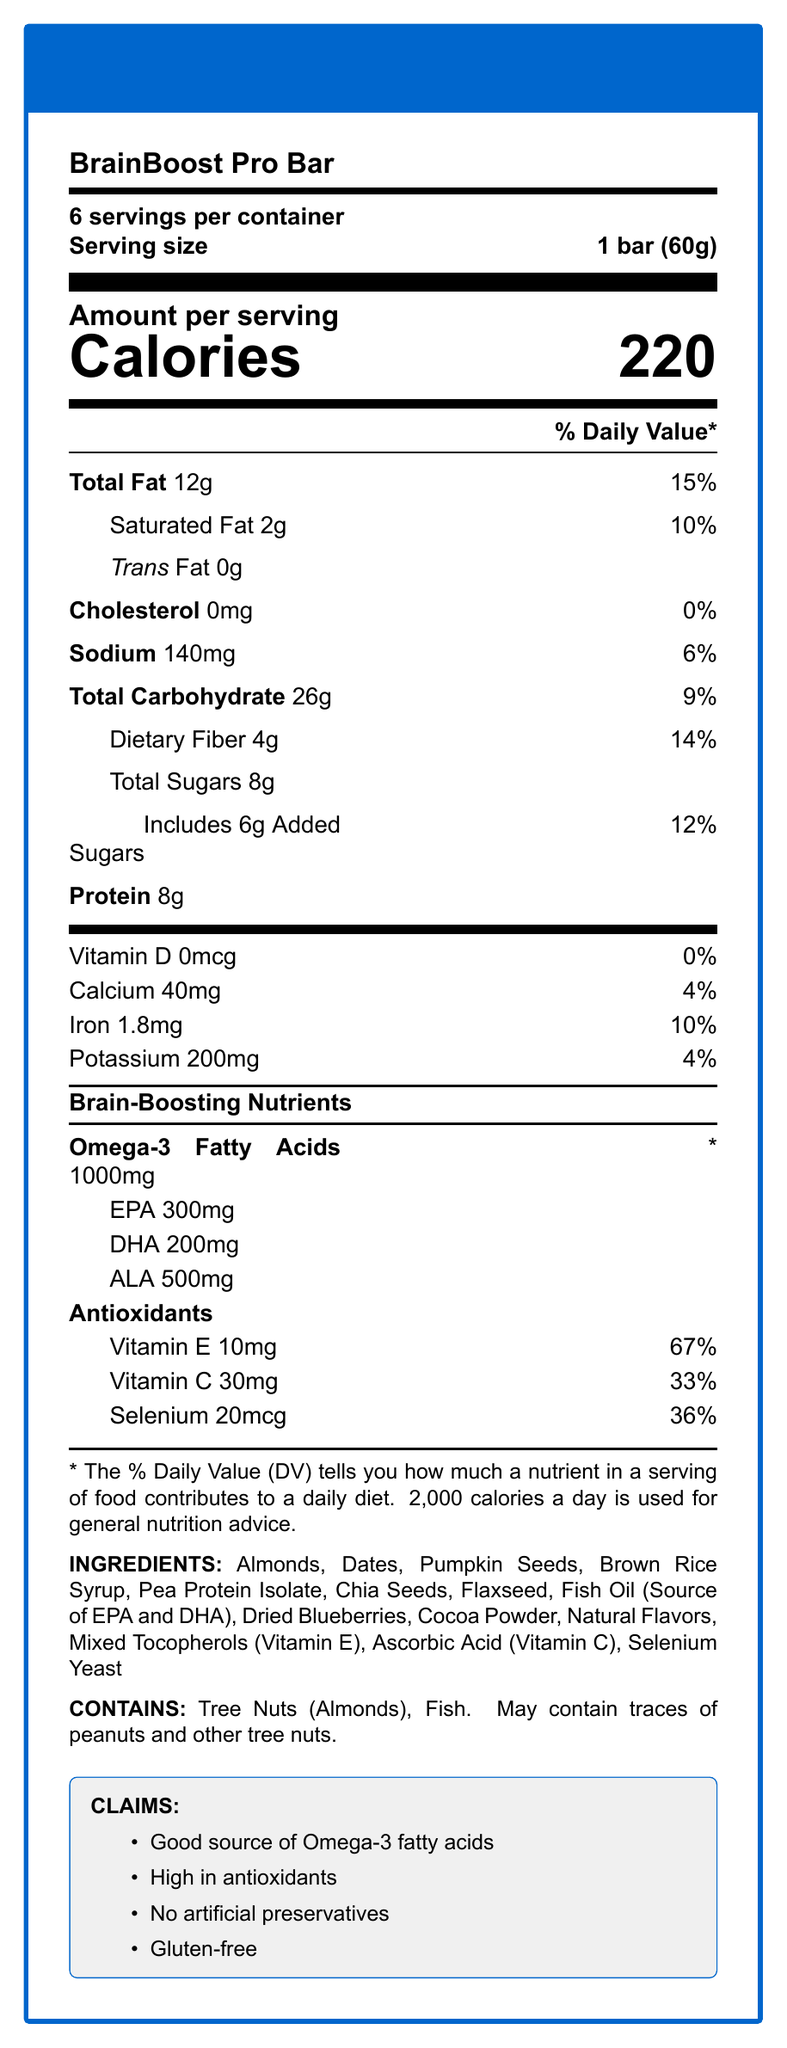what is the serving size for BrainBoost Pro Bar? The serving size is explicitly stated as "1 bar (60g)" in the document.
Answer: 1 bar (60g) how many servings are in one container of BrainBoost Pro Bar? The document specifies "6 servings per container".
Answer: 6 how much omega-3 fatty acids does one serving contain? The amount of omega-3 fatty acids is clearly listed as "1000mg".
Answer: 1000mg what percentage of the daily value is the vitamin E in BrainBoost Pro Bar? The document indicates that Vitamin E is at 67% of the daily value.
Answer: 67% what are the three types of omega-3 fatty acids listed in the document? EPA, DHA, and ALA are mentioned as the types of omega-3 fatty acids.
Answer: EPA, DHA, ALA how much protein does one serving of BrainBoost Pro Bar contain? The protein content is listed as "8g" per serving.
Answer: 8g what are the antioxidant vitamins listed for BrainBoost Pro Bar? The antioxidants listed are Vitamin E, Vitamin C, and Selenium.
Answer: Vitamin E, Vitamin C, Selenium how many calories are in one serving of BrainBoost Pro Bar? The calorie count per serving is clearly stated as "220".
Answer: 220 what is the total fat content in one serving of BrainBoost Pro Bar? The document indicates that the total fat content is "12g".
Answer: 12g how much iron does one serving contain as a percentage of the daily value? The iron percentage of the daily value is marked as "10%".
Answer: 10% which of the following is NOT an ingredient in BrainBoost Pro Bar? A. Almonds B. Chia Seeds C. Honey D. Cocoa Powder Honey is not listed among the ingredients of BrainBoost Pro Bar.
Answer: C. Honey what claim is mentioned about artificial preservatives in BrainBoost Pro Bar? A. Contains artificial preservatives B. No artificial preservatives C. Low artificial preservatives D. Rich in artificial preservatives The claim "No artificial preservatives" is specifically mentioned in the document.
Answer: B. No artificial preservatives does BrainBoost Pro Bar contain any cholesterol? The document lists cholesterol as "0mg", indicating there is no cholesterol.
Answer: No does BrainBoost Pro Bar contain any allergens? The document states that it contains tree nuts (almonds) and fish, and may contain traces of peanuts and other tree nuts.
Answer: Yes summarize the entire document. The document provides comprehensive nutrition facts for BrainBoost Pro Bar, emphasizing omega-3 fatty acids and antioxidants. It details the serving size, calories, macro and micronutrients, ingredients, allergens, and marketing claims.
Answer: BrainBoost Pro Bar is a brain-boosting snack bar with detailed nutrition information. It contains 220 calories per serving (1 bar, 60g), with 6 servings in each container. The bar is rich in omega-3 fatty acids (1000mg) and antioxidants like Vitamin E, Vitamin C, and Selenium. It contains 12g of total fat, 8g of protein, and 26g of carbohydrates per serving. Ingredients include almonds, dates, pumpkin seeds, and more, with claims of being a good source of omega-3, high in antioxidants, and gluten-free. It may pose allergen risks due to tree nuts and fish. what percentage of the daily value of dietary fiber does one serving of BrainBoost Pro Bar provide? The percentage of daily value for dietary fiber is listed as 14%.
Answer: 14% how much EPA is in one serving of BrainBoost Pro Bar? The document specifies that there are 300mg of EPA per serving.
Answer: 300mg can the amount of omega-3 fatty acids be derived from other nutrients within the document? The amount of omega-3 fatty acids is explicitly listed and doesn't need derivation from other values.
Answer: No, it is clearly listed. 